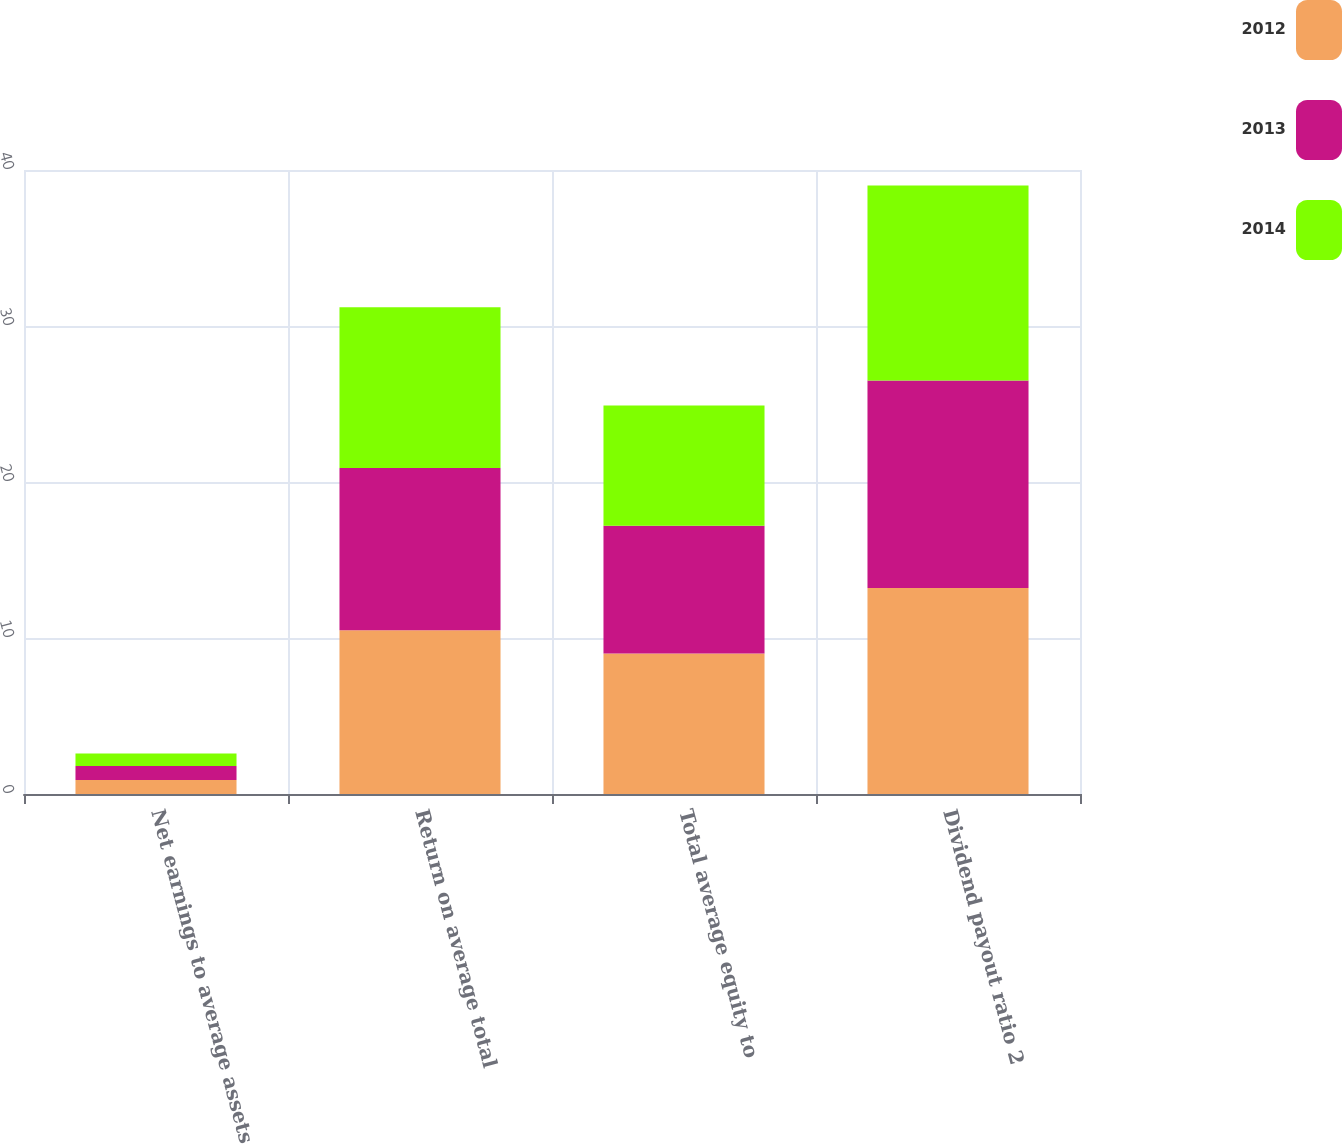Convert chart to OTSL. <chart><loc_0><loc_0><loc_500><loc_500><stacked_bar_chart><ecel><fcel>Net earnings to average assets<fcel>Return on average total<fcel>Total average equity to<fcel>Dividend payout ratio 2<nl><fcel>2012<fcel>0.9<fcel>10.5<fcel>9<fcel>13.2<nl><fcel>2013<fcel>0.9<fcel>10.4<fcel>8.2<fcel>13.3<nl><fcel>2014<fcel>0.8<fcel>10.3<fcel>7.7<fcel>12.5<nl></chart> 